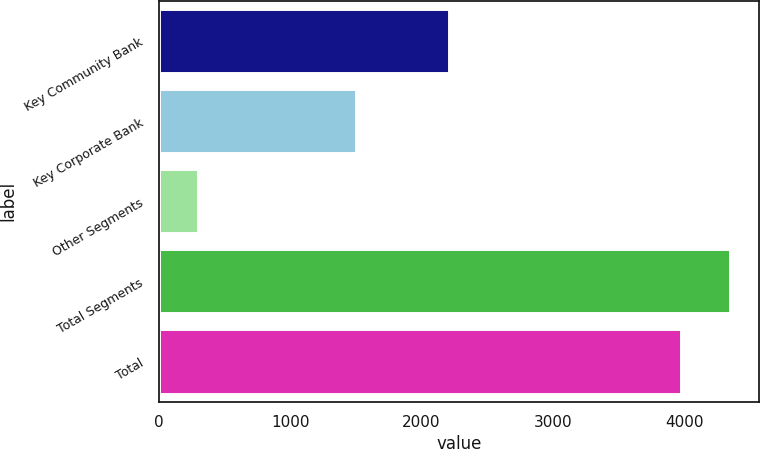Convert chart. <chart><loc_0><loc_0><loc_500><loc_500><bar_chart><fcel>Key Community Bank<fcel>Key Corporate Bank<fcel>Other Segments<fcel>Total Segments<fcel>Total<nl><fcel>2206<fcel>1499<fcel>299<fcel>4350.5<fcel>3980<nl></chart> 